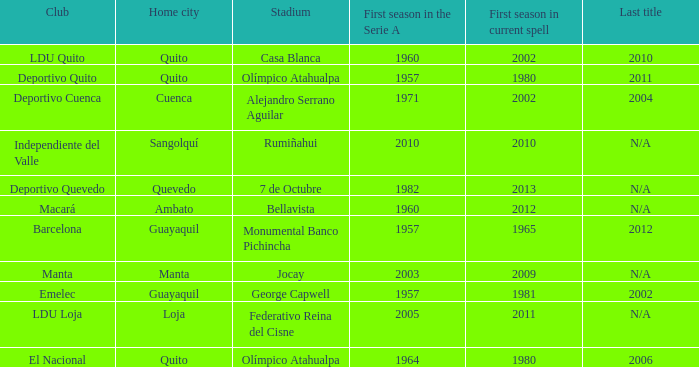Name the last title for cuenca 2004.0. 